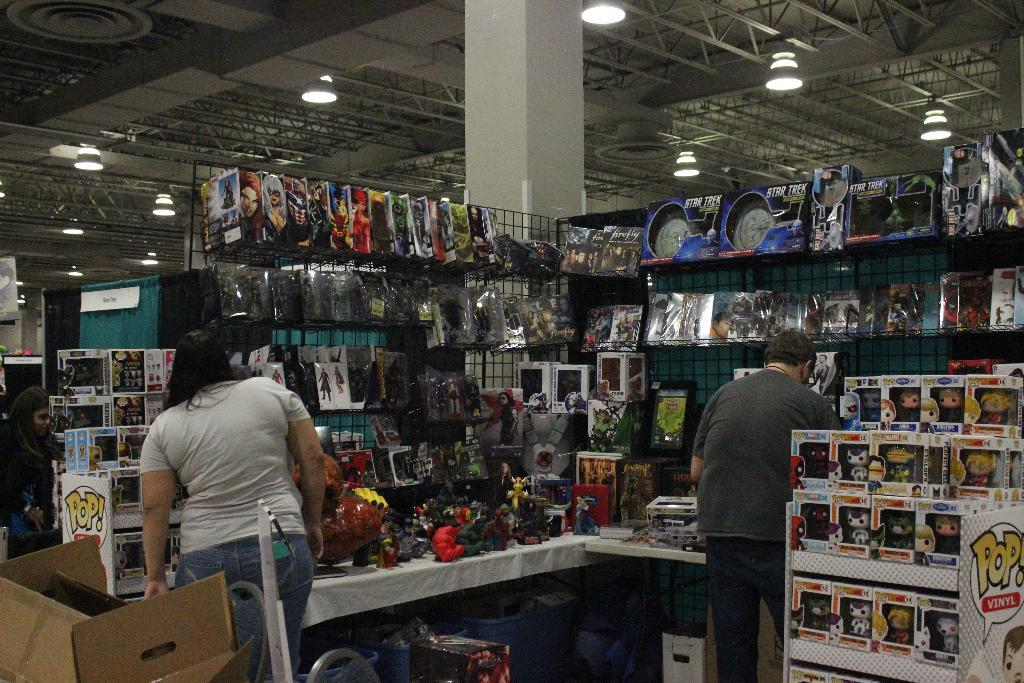<image>
Offer a succinct explanation of the picture presented. Two customers looking at products on display and a PoP collection display in the corner. 